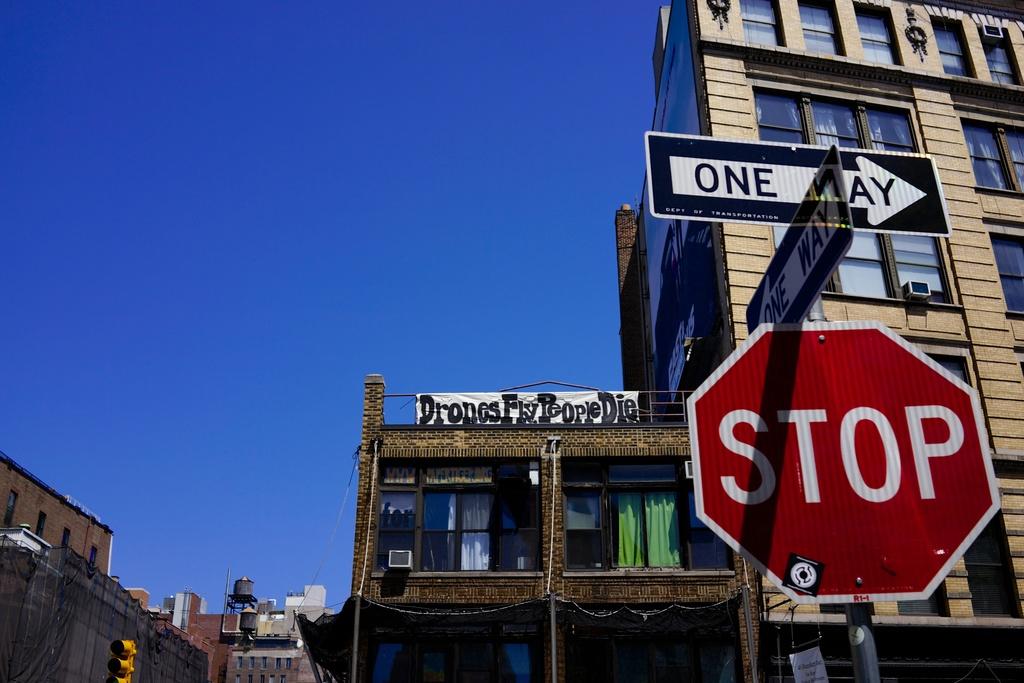What is the red sign telling us to do?
Offer a terse response. Stop. 